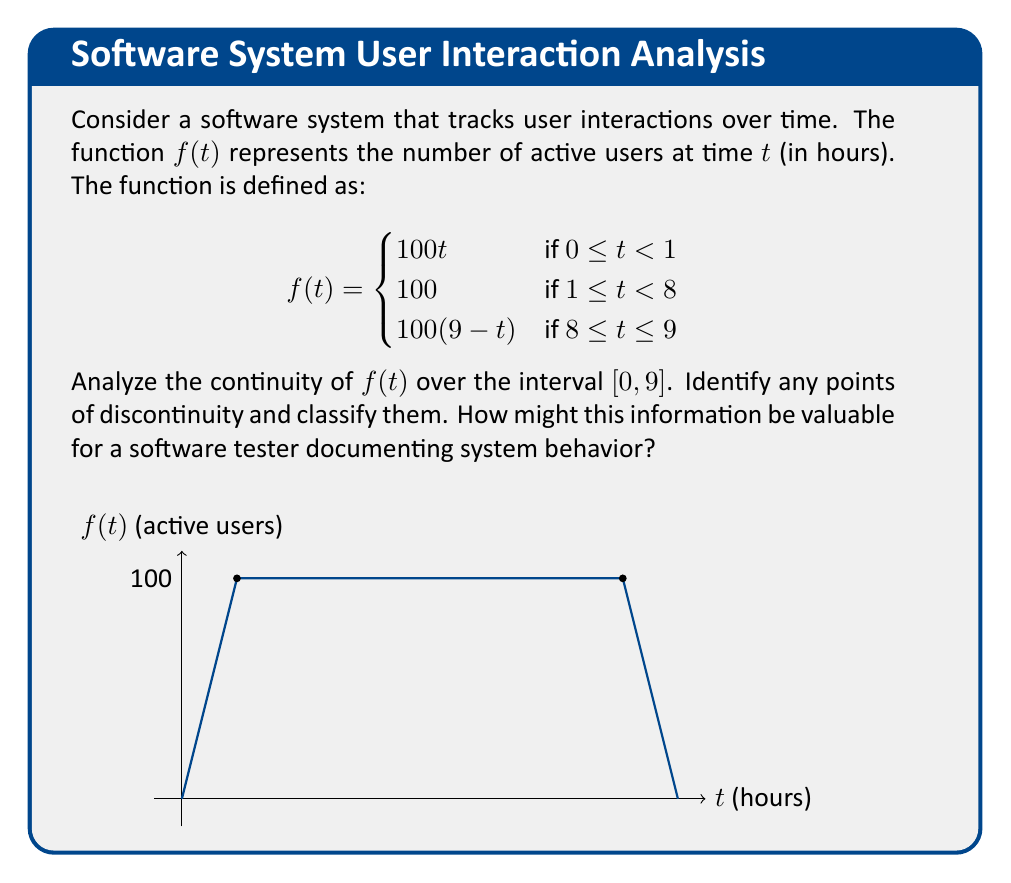Can you answer this question? To analyze the continuity of $f(t)$, we need to examine the function at each piece and at the transition points:

1. For $0 \leq t < 1$: $f(t) = 100t$
   This is a continuous function within its domain.

2. For $1 \leq t < 8$: $f(t) = 100$
   This is a constant function, which is continuous within its domain.

3. For $8 \leq t \leq 9$: $f(t) = 100(9-t)$
   This is a continuous function within its domain.

Now, we need to check the transition points:

4. At $t = 1$:
   Left limit: $\lim_{t \to 1^-} f(t) = \lim_{t \to 1^-} 100t = 100$
   Right limit: $\lim_{t \to 1^+} f(t) = 100$
   $f(1) = 100$
   All three values are equal, so $f(t)$ is continuous at $t = 1$.

5. At $t = 8$:
   Left limit: $\lim_{t \to 8^-} f(t) = 100$
   Right limit: $\lim_{t \to 8^+} f(t) = \lim_{t \to 8^+} 100(9-t) = 100$
   $f(8) = 100$
   All three values are equal, so $f(t)$ is continuous at $t = 8$.

Therefore, $f(t)$ is continuous over the entire interval $[0, 9]$. There are no points of discontinuity.

For a software tester documenting system behavior, this information is valuable because:
1. It shows that the user interaction model doesn't have any sudden jumps or gaps, which could indicate system stability.
2. The smooth transitions at $t = 1$ and $t = 8$ suggest that the system handles changes in user activity gracefully.
3. The piecewise nature of the function allows for different testing strategies for different time periods (e.g., ramp-up, steady-state, and ramp-down phases).
4. Continuity ensures that small changes in time lead to small changes in user count, which is important for predicting system load and performance.
Answer: $f(t)$ is continuous on $[0, 9]$ with no discontinuities. 